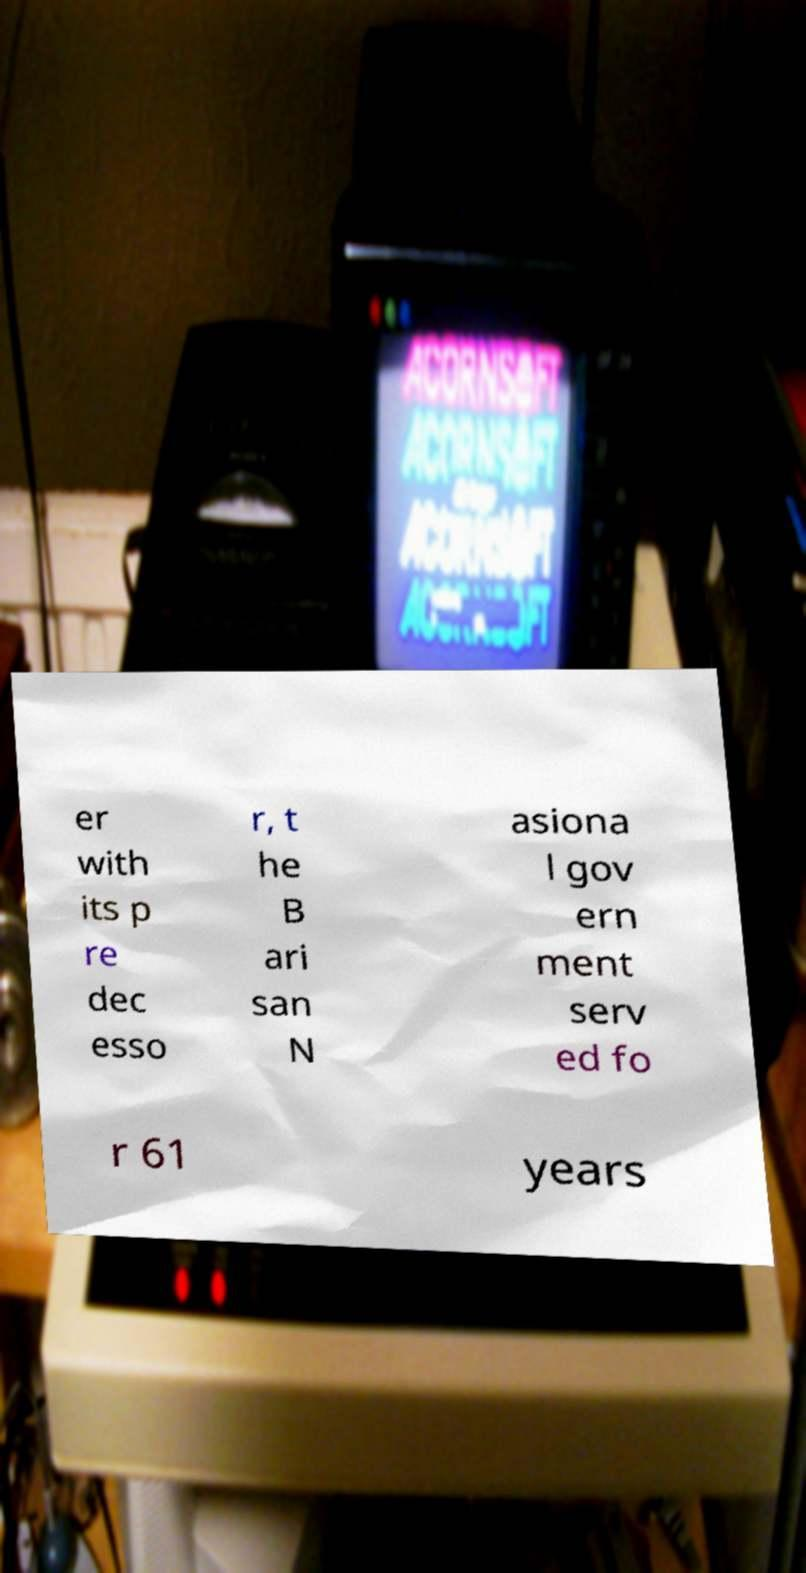What messages or text are displayed in this image? I need them in a readable, typed format. er with its p re dec esso r, t he B ari san N asiona l gov ern ment serv ed fo r 61 years 